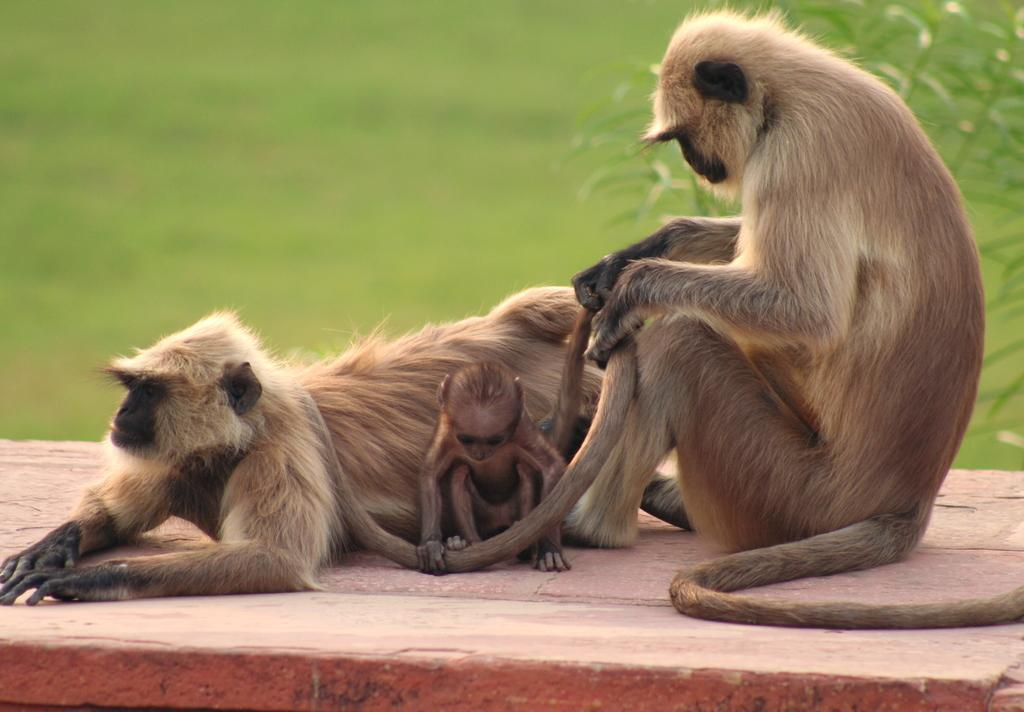How many monkeys are present in the image? There are two monkeys in the image. What is the child monkey doing in the image? The child monkey is on a platform in the image. Can you describe the background of the image? The background of the image is blurred. Who is distributing the parcels to the monkeys in the image? There are no parcels or distribution activity present in the image. 